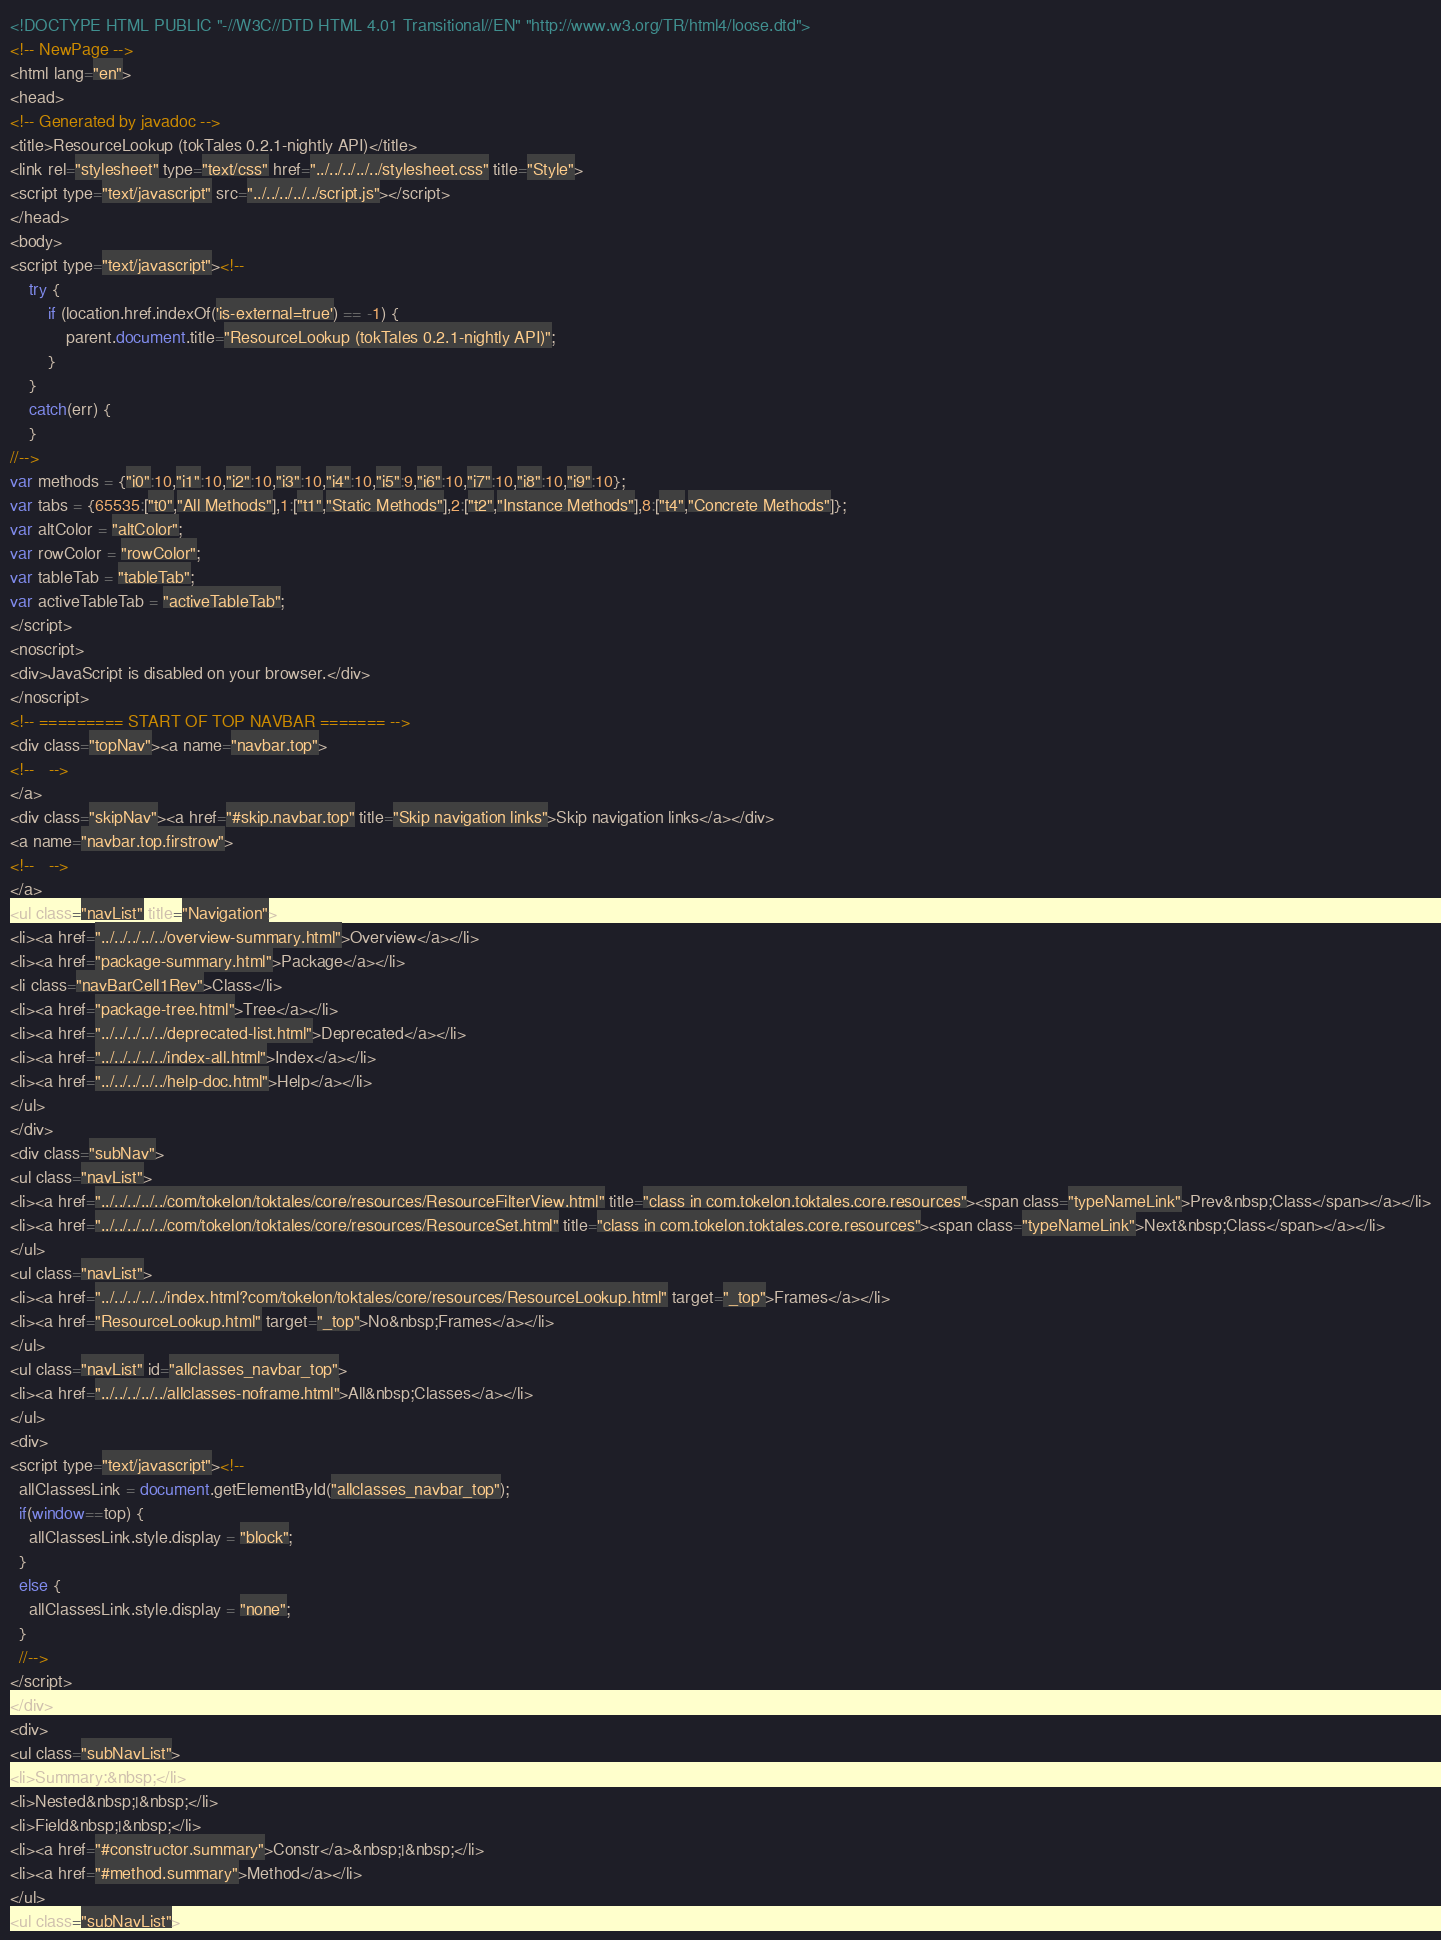Convert code to text. <code><loc_0><loc_0><loc_500><loc_500><_HTML_><!DOCTYPE HTML PUBLIC "-//W3C//DTD HTML 4.01 Transitional//EN" "http://www.w3.org/TR/html4/loose.dtd">
<!-- NewPage -->
<html lang="en">
<head>
<!-- Generated by javadoc -->
<title>ResourceLookup (tokTales 0.2.1-nightly API)</title>
<link rel="stylesheet" type="text/css" href="../../../../../stylesheet.css" title="Style">
<script type="text/javascript" src="../../../../../script.js"></script>
</head>
<body>
<script type="text/javascript"><!--
    try {
        if (location.href.indexOf('is-external=true') == -1) {
            parent.document.title="ResourceLookup (tokTales 0.2.1-nightly API)";
        }
    }
    catch(err) {
    }
//-->
var methods = {"i0":10,"i1":10,"i2":10,"i3":10,"i4":10,"i5":9,"i6":10,"i7":10,"i8":10,"i9":10};
var tabs = {65535:["t0","All Methods"],1:["t1","Static Methods"],2:["t2","Instance Methods"],8:["t4","Concrete Methods"]};
var altColor = "altColor";
var rowColor = "rowColor";
var tableTab = "tableTab";
var activeTableTab = "activeTableTab";
</script>
<noscript>
<div>JavaScript is disabled on your browser.</div>
</noscript>
<!-- ========= START OF TOP NAVBAR ======= -->
<div class="topNav"><a name="navbar.top">
<!--   -->
</a>
<div class="skipNav"><a href="#skip.navbar.top" title="Skip navigation links">Skip navigation links</a></div>
<a name="navbar.top.firstrow">
<!--   -->
</a>
<ul class="navList" title="Navigation">
<li><a href="../../../../../overview-summary.html">Overview</a></li>
<li><a href="package-summary.html">Package</a></li>
<li class="navBarCell1Rev">Class</li>
<li><a href="package-tree.html">Tree</a></li>
<li><a href="../../../../../deprecated-list.html">Deprecated</a></li>
<li><a href="../../../../../index-all.html">Index</a></li>
<li><a href="../../../../../help-doc.html">Help</a></li>
</ul>
</div>
<div class="subNav">
<ul class="navList">
<li><a href="../../../../../com/tokelon/toktales/core/resources/ResourceFilterView.html" title="class in com.tokelon.toktales.core.resources"><span class="typeNameLink">Prev&nbsp;Class</span></a></li>
<li><a href="../../../../../com/tokelon/toktales/core/resources/ResourceSet.html" title="class in com.tokelon.toktales.core.resources"><span class="typeNameLink">Next&nbsp;Class</span></a></li>
</ul>
<ul class="navList">
<li><a href="../../../../../index.html?com/tokelon/toktales/core/resources/ResourceLookup.html" target="_top">Frames</a></li>
<li><a href="ResourceLookup.html" target="_top">No&nbsp;Frames</a></li>
</ul>
<ul class="navList" id="allclasses_navbar_top">
<li><a href="../../../../../allclasses-noframe.html">All&nbsp;Classes</a></li>
</ul>
<div>
<script type="text/javascript"><!--
  allClassesLink = document.getElementById("allclasses_navbar_top");
  if(window==top) {
    allClassesLink.style.display = "block";
  }
  else {
    allClassesLink.style.display = "none";
  }
  //-->
</script>
</div>
<div>
<ul class="subNavList">
<li>Summary:&nbsp;</li>
<li>Nested&nbsp;|&nbsp;</li>
<li>Field&nbsp;|&nbsp;</li>
<li><a href="#constructor.summary">Constr</a>&nbsp;|&nbsp;</li>
<li><a href="#method.summary">Method</a></li>
</ul>
<ul class="subNavList"></code> 